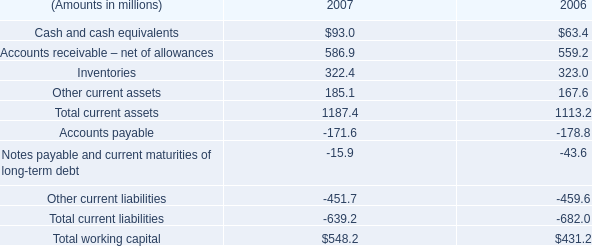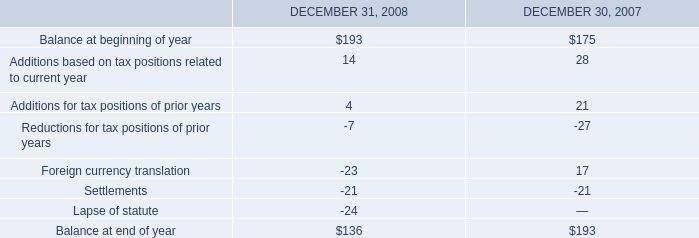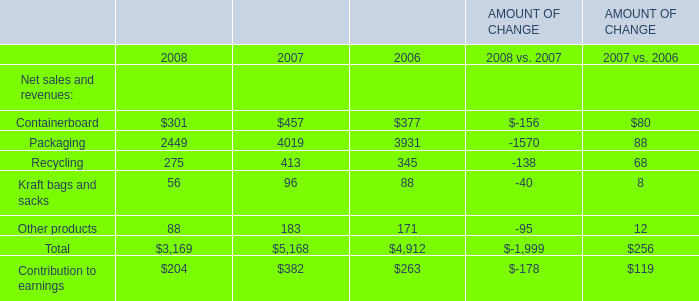What was the average value of the Packaging in the years where Containerboard is positive? 
Computations: (((2449 + 4019) + 3931) / 3)
Answer: 3466.33333. 